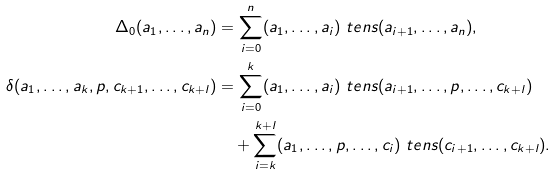Convert formula to latex. <formula><loc_0><loc_0><loc_500><loc_500>\Delta _ { 0 } ( a _ { 1 } , \dots , a _ { n } ) & = \sum _ { i = 0 } ^ { n } ( a _ { 1 } , \dots , a _ { i } ) \ t e n s ( a _ { i + 1 } , \dots , a _ { n } ) , \\ \delta ( a _ { 1 } , \dots , a _ { k } , p , c _ { k + 1 } , \dots , c _ { k + l } ) & = \sum _ { i = 0 } ^ { k } ( a _ { 1 } , \dots , a _ { i } ) \ t e n s ( a _ { i + 1 } , \dots , p , \dots , c _ { k + l } ) \\ & \quad + \sum _ { i = k } ^ { k + l } ( a _ { 1 } , \dots , p , \dots , c _ { i } ) \ t e n s ( c _ { i + 1 } , \dots , c _ { k + l } ) .</formula> 